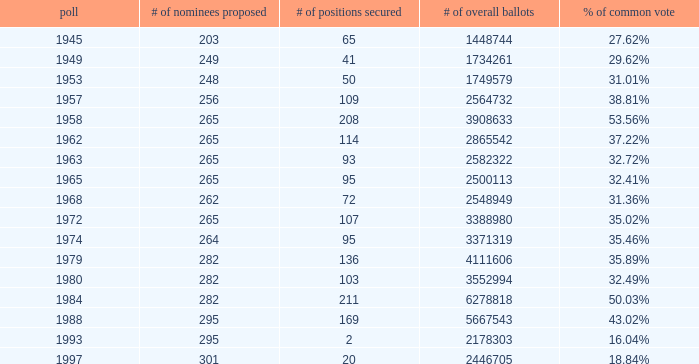What is the # of seats one for the election in 1974? 95.0. 